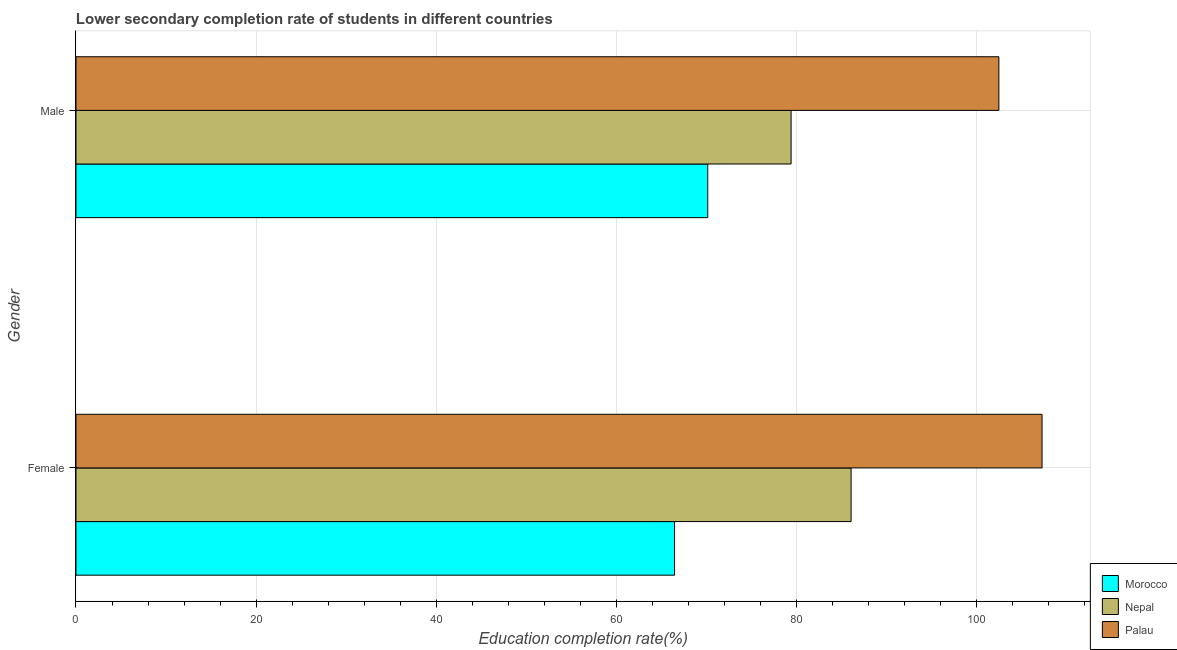How many different coloured bars are there?
Give a very brief answer. 3. How many bars are there on the 2nd tick from the top?
Offer a very short reply. 3. What is the education completion rate of male students in Nepal?
Offer a very short reply. 79.41. Across all countries, what is the maximum education completion rate of female students?
Make the answer very short. 107.27. Across all countries, what is the minimum education completion rate of female students?
Your response must be concise. 66.47. In which country was the education completion rate of male students maximum?
Make the answer very short. Palau. In which country was the education completion rate of female students minimum?
Keep it short and to the point. Morocco. What is the total education completion rate of male students in the graph?
Your answer should be compact. 252.04. What is the difference between the education completion rate of female students in Palau and that in Nepal?
Offer a terse response. 21.2. What is the difference between the education completion rate of male students in Palau and the education completion rate of female students in Nepal?
Your answer should be very brief. 16.41. What is the average education completion rate of male students per country?
Your response must be concise. 84.01. What is the difference between the education completion rate of male students and education completion rate of female students in Palau?
Provide a short and direct response. -4.79. What is the ratio of the education completion rate of male students in Nepal to that in Palau?
Offer a very short reply. 0.77. What does the 3rd bar from the top in Male represents?
Your answer should be very brief. Morocco. What does the 1st bar from the bottom in Male represents?
Keep it short and to the point. Morocco. How many bars are there?
Provide a short and direct response. 6. How many countries are there in the graph?
Offer a terse response. 3. Are the values on the major ticks of X-axis written in scientific E-notation?
Your answer should be very brief. No. Does the graph contain grids?
Ensure brevity in your answer.  Yes. How many legend labels are there?
Ensure brevity in your answer.  3. How are the legend labels stacked?
Provide a short and direct response. Vertical. What is the title of the graph?
Provide a succinct answer. Lower secondary completion rate of students in different countries. Does "Lesotho" appear as one of the legend labels in the graph?
Your answer should be very brief. No. What is the label or title of the X-axis?
Your answer should be very brief. Education completion rate(%). What is the label or title of the Y-axis?
Offer a terse response. Gender. What is the Education completion rate(%) in Morocco in Female?
Provide a short and direct response. 66.47. What is the Education completion rate(%) in Nepal in Female?
Offer a very short reply. 86.07. What is the Education completion rate(%) in Palau in Female?
Offer a very short reply. 107.27. What is the Education completion rate(%) of Morocco in Male?
Provide a succinct answer. 70.15. What is the Education completion rate(%) of Nepal in Male?
Your response must be concise. 79.41. What is the Education completion rate(%) in Palau in Male?
Your answer should be compact. 102.48. Across all Gender, what is the maximum Education completion rate(%) in Morocco?
Offer a terse response. 70.15. Across all Gender, what is the maximum Education completion rate(%) in Nepal?
Provide a succinct answer. 86.07. Across all Gender, what is the maximum Education completion rate(%) of Palau?
Your response must be concise. 107.27. Across all Gender, what is the minimum Education completion rate(%) in Morocco?
Offer a very short reply. 66.47. Across all Gender, what is the minimum Education completion rate(%) in Nepal?
Keep it short and to the point. 79.41. Across all Gender, what is the minimum Education completion rate(%) of Palau?
Give a very brief answer. 102.48. What is the total Education completion rate(%) of Morocco in the graph?
Your answer should be compact. 136.62. What is the total Education completion rate(%) in Nepal in the graph?
Ensure brevity in your answer.  165.48. What is the total Education completion rate(%) in Palau in the graph?
Give a very brief answer. 209.75. What is the difference between the Education completion rate(%) in Morocco in Female and that in Male?
Your answer should be compact. -3.68. What is the difference between the Education completion rate(%) of Nepal in Female and that in Male?
Offer a terse response. 6.66. What is the difference between the Education completion rate(%) in Palau in Female and that in Male?
Ensure brevity in your answer.  4.79. What is the difference between the Education completion rate(%) in Morocco in Female and the Education completion rate(%) in Nepal in Male?
Your answer should be compact. -12.94. What is the difference between the Education completion rate(%) in Morocco in Female and the Education completion rate(%) in Palau in Male?
Your answer should be very brief. -36.01. What is the difference between the Education completion rate(%) in Nepal in Female and the Education completion rate(%) in Palau in Male?
Ensure brevity in your answer.  -16.41. What is the average Education completion rate(%) of Morocco per Gender?
Provide a succinct answer. 68.31. What is the average Education completion rate(%) in Nepal per Gender?
Your answer should be very brief. 82.74. What is the average Education completion rate(%) in Palau per Gender?
Your answer should be compact. 104.88. What is the difference between the Education completion rate(%) of Morocco and Education completion rate(%) of Nepal in Female?
Ensure brevity in your answer.  -19.6. What is the difference between the Education completion rate(%) of Morocco and Education completion rate(%) of Palau in Female?
Provide a short and direct response. -40.81. What is the difference between the Education completion rate(%) in Nepal and Education completion rate(%) in Palau in Female?
Give a very brief answer. -21.2. What is the difference between the Education completion rate(%) in Morocco and Education completion rate(%) in Nepal in Male?
Ensure brevity in your answer.  -9.26. What is the difference between the Education completion rate(%) of Morocco and Education completion rate(%) of Palau in Male?
Make the answer very short. -32.33. What is the difference between the Education completion rate(%) in Nepal and Education completion rate(%) in Palau in Male?
Your answer should be compact. -23.07. What is the ratio of the Education completion rate(%) in Morocco in Female to that in Male?
Keep it short and to the point. 0.95. What is the ratio of the Education completion rate(%) of Nepal in Female to that in Male?
Offer a very short reply. 1.08. What is the ratio of the Education completion rate(%) in Palau in Female to that in Male?
Give a very brief answer. 1.05. What is the difference between the highest and the second highest Education completion rate(%) in Morocco?
Keep it short and to the point. 3.68. What is the difference between the highest and the second highest Education completion rate(%) of Nepal?
Your answer should be compact. 6.66. What is the difference between the highest and the second highest Education completion rate(%) in Palau?
Keep it short and to the point. 4.79. What is the difference between the highest and the lowest Education completion rate(%) of Morocco?
Offer a terse response. 3.68. What is the difference between the highest and the lowest Education completion rate(%) in Nepal?
Provide a short and direct response. 6.66. What is the difference between the highest and the lowest Education completion rate(%) of Palau?
Provide a short and direct response. 4.79. 